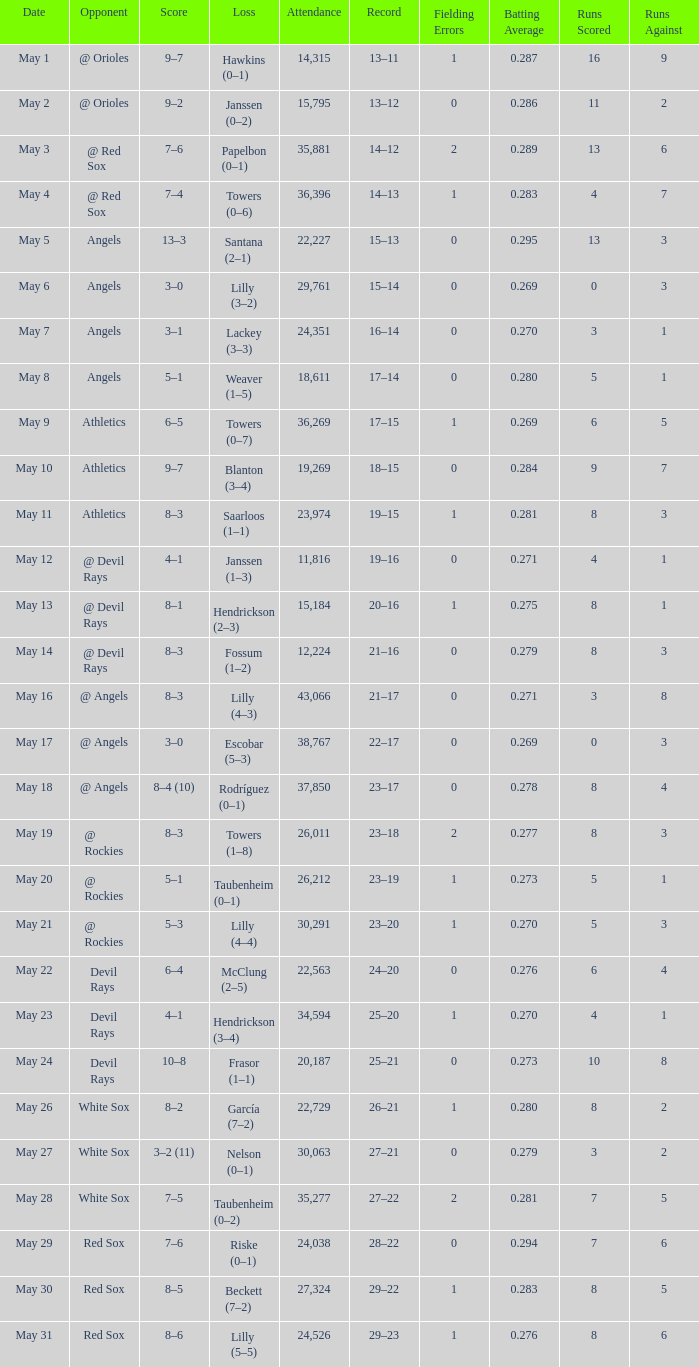Help me parse the entirety of this table. {'header': ['Date', 'Opponent', 'Score', 'Loss', 'Attendance', 'Record', 'Fielding Errors', 'Batting Average', 'Runs Scored', 'Runs Against'], 'rows': [['May 1', '@ Orioles', '9–7', 'Hawkins (0–1)', '14,315', '13–11', '1', '0.287', '16', '9'], ['May 2', '@ Orioles', '9–2', 'Janssen (0–2)', '15,795', '13–12', '0', '0.286', '11', '2'], ['May 3', '@ Red Sox', '7–6', 'Papelbon (0–1)', '35,881', '14–12', '2', '0.289', '13', '6'], ['May 4', '@ Red Sox', '7–4', 'Towers (0–6)', '36,396', '14–13', '1', '0.283', '4', '7'], ['May 5', 'Angels', '13–3', 'Santana (2–1)', '22,227', '15–13', '0', '0.295', '13', '3'], ['May 6', 'Angels', '3–0', 'Lilly (3–2)', '29,761', '15–14', '0', '0.269', '0', '3'], ['May 7', 'Angels', '3–1', 'Lackey (3–3)', '24,351', '16–14', '0', '0.270', '3', '1'], ['May 8', 'Angels', '5–1', 'Weaver (1–5)', '18,611', '17–14', '0', '0.280', '5', '1'], ['May 9', 'Athletics', '6–5', 'Towers (0–7)', '36,269', '17–15', '1', '0.269', '6', '5'], ['May 10', 'Athletics', '9–7', 'Blanton (3–4)', '19,269', '18–15', '0', '0.284', '9', '7'], ['May 11', 'Athletics', '8–3', 'Saarloos (1–1)', '23,974', '19–15', '1', '0.281', '8', '3'], ['May 12', '@ Devil Rays', '4–1', 'Janssen (1–3)', '11,816', '19–16', '0', '0.271', '4', '1'], ['May 13', '@ Devil Rays', '8–1', 'Hendrickson (2–3)', '15,184', '20–16', '1', '0.275', '8', '1'], ['May 14', '@ Devil Rays', '8–3', 'Fossum (1–2)', '12,224', '21–16', '0', '0.279', '8', '3'], ['May 16', '@ Angels', '8–3', 'Lilly (4–3)', '43,066', '21–17', '0', '0.271', '3', '8'], ['May 17', '@ Angels', '3–0', 'Escobar (5–3)', '38,767', '22–17', '0', '0.269', '0', '3'], ['May 18', '@ Angels', '8–4 (10)', 'Rodríguez (0–1)', '37,850', '23–17', '0', '0.278', '8', '4'], ['May 19', '@ Rockies', '8–3', 'Towers (1–8)', '26,011', '23–18', '2', '0.277', '8', '3'], ['May 20', '@ Rockies', '5–1', 'Taubenheim (0–1)', '26,212', '23–19', '1', '0.273', '5', '1'], ['May 21', '@ Rockies', '5–3', 'Lilly (4–4)', '30,291', '23–20', '1', '0.270', '5', '3'], ['May 22', 'Devil Rays', '6–4', 'McClung (2–5)', '22,563', '24–20', '0', '0.276', '6', '4'], ['May 23', 'Devil Rays', '4–1', 'Hendrickson (3–4)', '34,594', '25–20', '1', '0.270', '4', '1'], ['May 24', 'Devil Rays', '10–8', 'Frasor (1–1)', '20,187', '25–21', '0', '0.273', '10', '8'], ['May 26', 'White Sox', '8–2', 'García (7–2)', '22,729', '26–21', '1', '0.280', '8', '2'], ['May 27', 'White Sox', '3–2 (11)', 'Nelson (0–1)', '30,063', '27–21', '0', '0.279', '3', '2'], ['May 28', 'White Sox', '7–5', 'Taubenheim (0–2)', '35,277', '27–22', '2', '0.281', '7', '5'], ['May 29', 'Red Sox', '7–6', 'Riske (0–1)', '24,038', '28–22', '0', '0.294', '7', '6'], ['May 30', 'Red Sox', '8–5', 'Beckett (7–2)', '27,324', '29–22', '1', '0.283', '8', '5'], ['May 31', 'Red Sox', '8–6', 'Lilly (5–5)', '24,526', '29–23', '1', '0.276', '8', '6']]} What was the average attendance for games with a loss of papelbon (0–1)? 35881.0. 